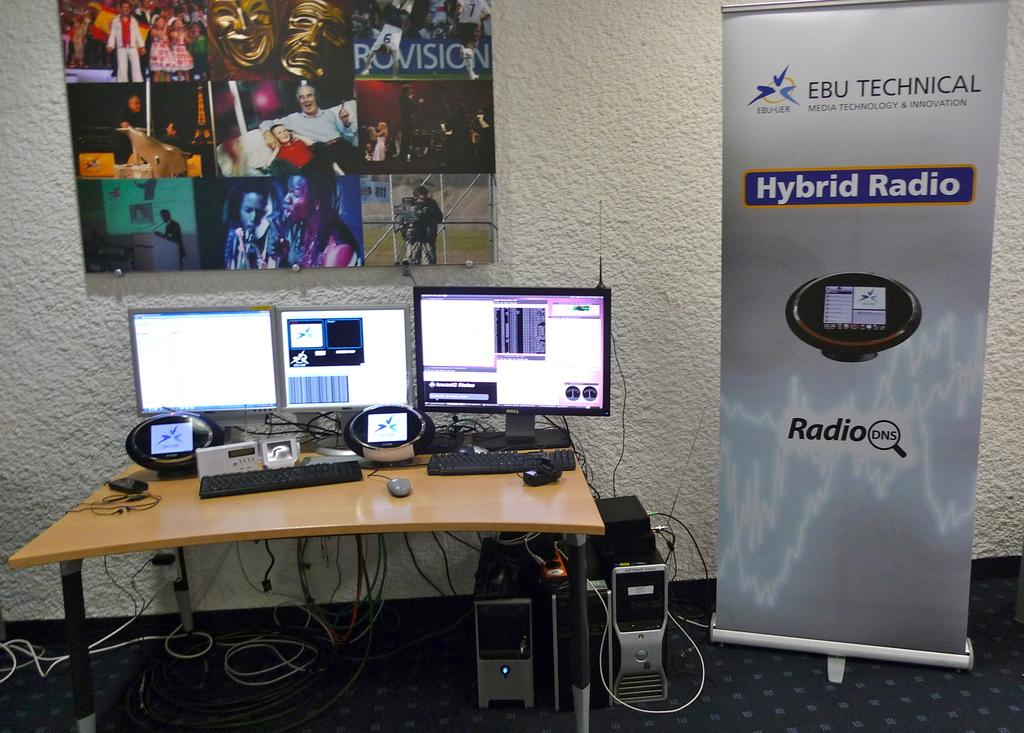Provide a one-sentence caption for the provided image. A Dell monitor sits to the right of 2 other monitors and to the left of a tall display advertising Hybrid Radio. 